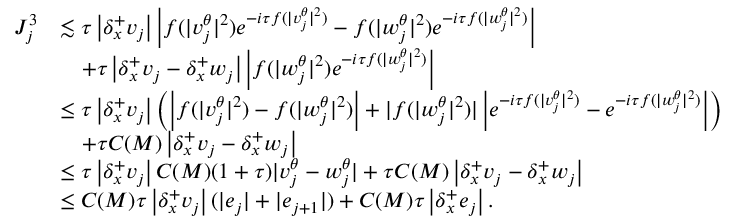Convert formula to latex. <formula><loc_0><loc_0><loc_500><loc_500>\begin{array} { r l } { J _ { j } ^ { 3 } } & { \lesssim \tau \left | { \delta _ { x } ^ { + } } v _ { j } \right | \left | f ( | v _ { j } ^ { \theta } | ^ { 2 } ) e ^ { - i \tau f ( | v _ { j } ^ { \theta } | ^ { 2 } ) } - f ( | w _ { j } ^ { \theta } | ^ { 2 } ) e ^ { - i \tau f ( | w _ { j } ^ { \theta } | ^ { 2 } ) } \right | } \\ & { \quad + \tau \left | { \delta _ { x } ^ { + } } v _ { j } - { \delta _ { x } ^ { + } } w _ { j } \right | \left | f ( | w _ { j } ^ { \theta } | ^ { 2 } ) e ^ { - i \tau f ( | w _ { j } ^ { \theta } | ^ { 2 } ) } \right | } \\ & { \leq \tau \left | { \delta _ { x } ^ { + } } v _ { j } \right | \left ( \left | f ( | v _ { j } ^ { \theta } | ^ { 2 } ) - f ( | w _ { j } ^ { \theta } | ^ { 2 } ) \right | + | f ( | w _ { j } ^ { \theta } | ^ { 2 } ) | \left | e ^ { - i \tau f ( | v _ { j } ^ { \theta } | ^ { 2 } ) } - e ^ { - i \tau f ( | w _ { j } ^ { \theta } | ^ { 2 } ) } \right | \right ) } \\ & { \quad + \tau C ( M ) \left | { \delta _ { x } ^ { + } } v _ { j } - { \delta _ { x } ^ { + } } w _ { j } \right | } \\ & { \leq \tau \left | { \delta _ { x } ^ { + } } v _ { j } \right | C ( M ) ( 1 + \tau ) | v _ { j } ^ { \theta } - w _ { j } ^ { \theta } | + \tau C ( M ) \left | { \delta _ { x } ^ { + } } v _ { j } - { \delta _ { x } ^ { + } } w _ { j } \right | } \\ & { \leq C ( M ) \tau \left | { \delta _ { x } ^ { + } } v _ { j } \right | ( | e _ { j } | + | e _ { j + 1 } | ) + C ( M ) \tau \left | { \delta _ { x } ^ { + } } e _ { j } \right | . } \end{array}</formula> 